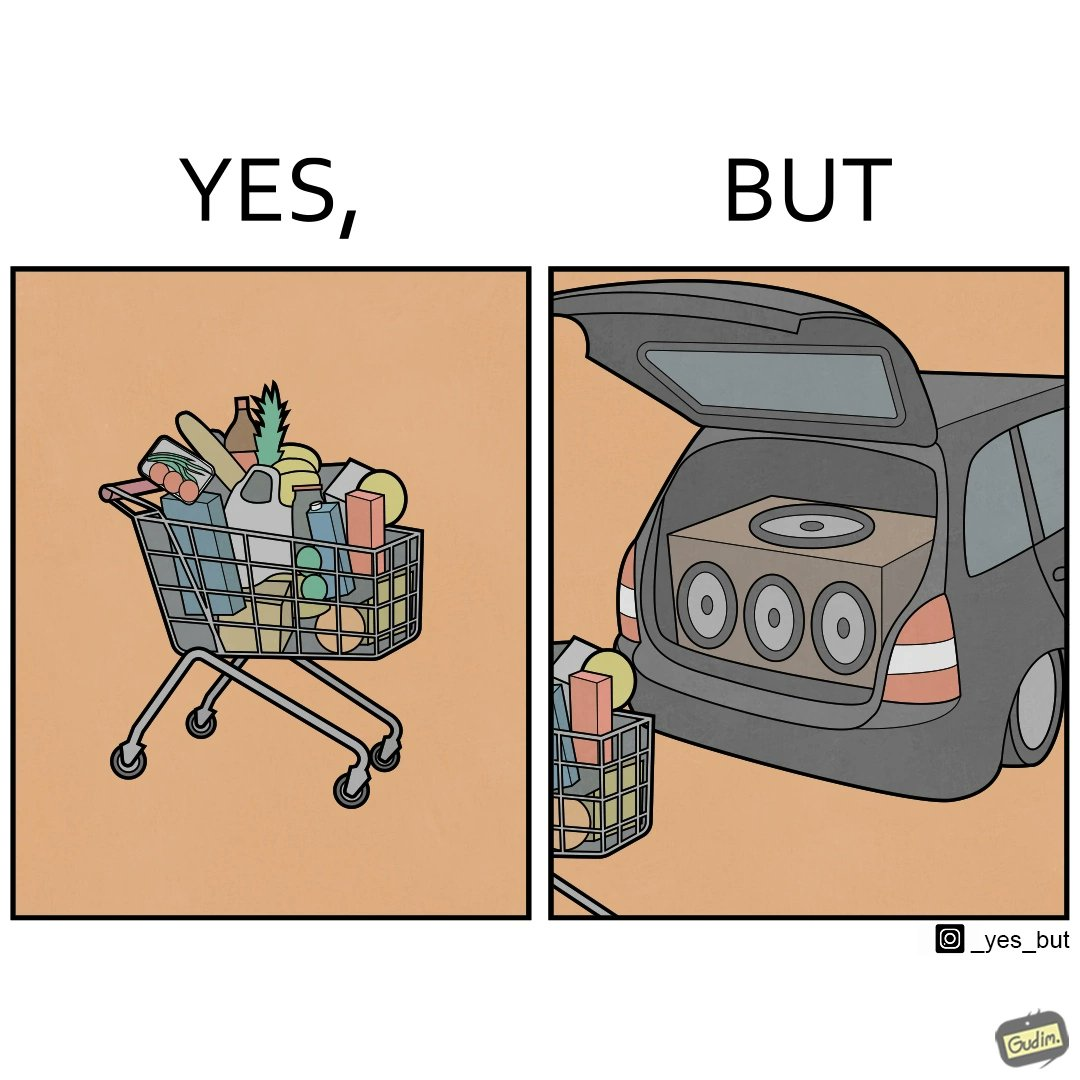Provide a description of this image. The image is ironic, because a car trunk was earlier designed to keep some extra luggage or things but people nowadays get speakers installed in the trunk which in turn reduces the space in the trunk and making it difficult for people to store the extra luggage in the trunk 